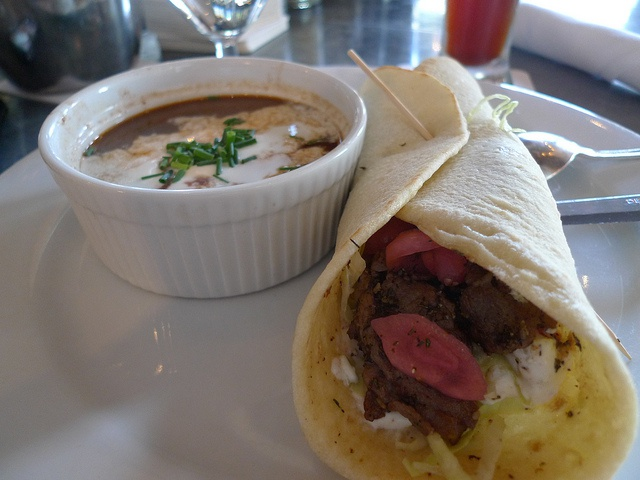Describe the objects in this image and their specific colors. I can see sandwich in black, olive, tan, and maroon tones, bowl in black, darkgray, and gray tones, dining table in black and gray tones, cup in black, maroon, gray, and brown tones, and wine glass in black, darkgray, gray, and white tones in this image. 